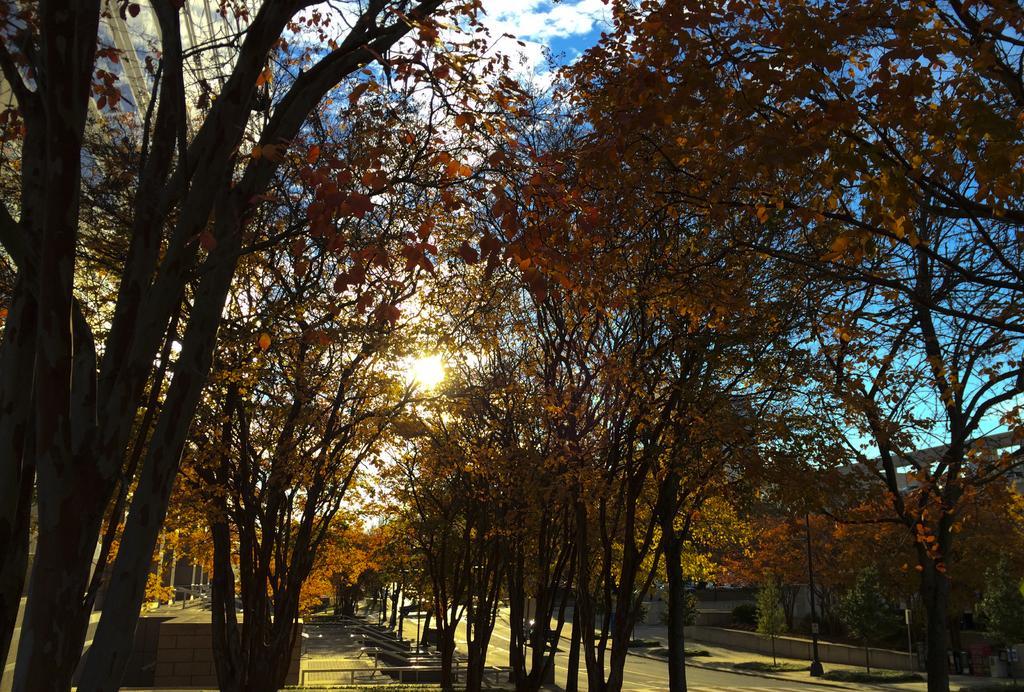Could you give a brief overview of what you see in this image? In this picture we can see vehicles on the road, trees, poles and in the background we can see the sky with clouds. 